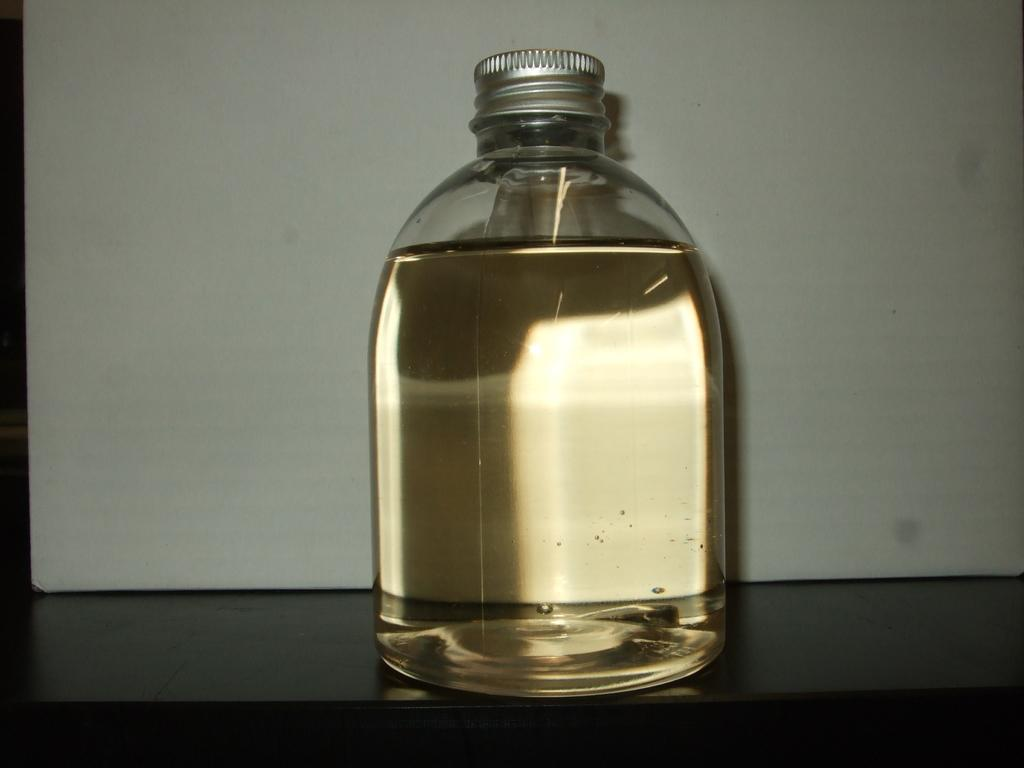What object can be seen in the image? There is a bottle in the image. What is inside the bottle? The bottle contains a solution. How many stars can be seen in the image? There are no stars visible in the image; it only contains a bottle with a solution. What type of tool is being used by the man in the image? There is no man or rake present in the image. 